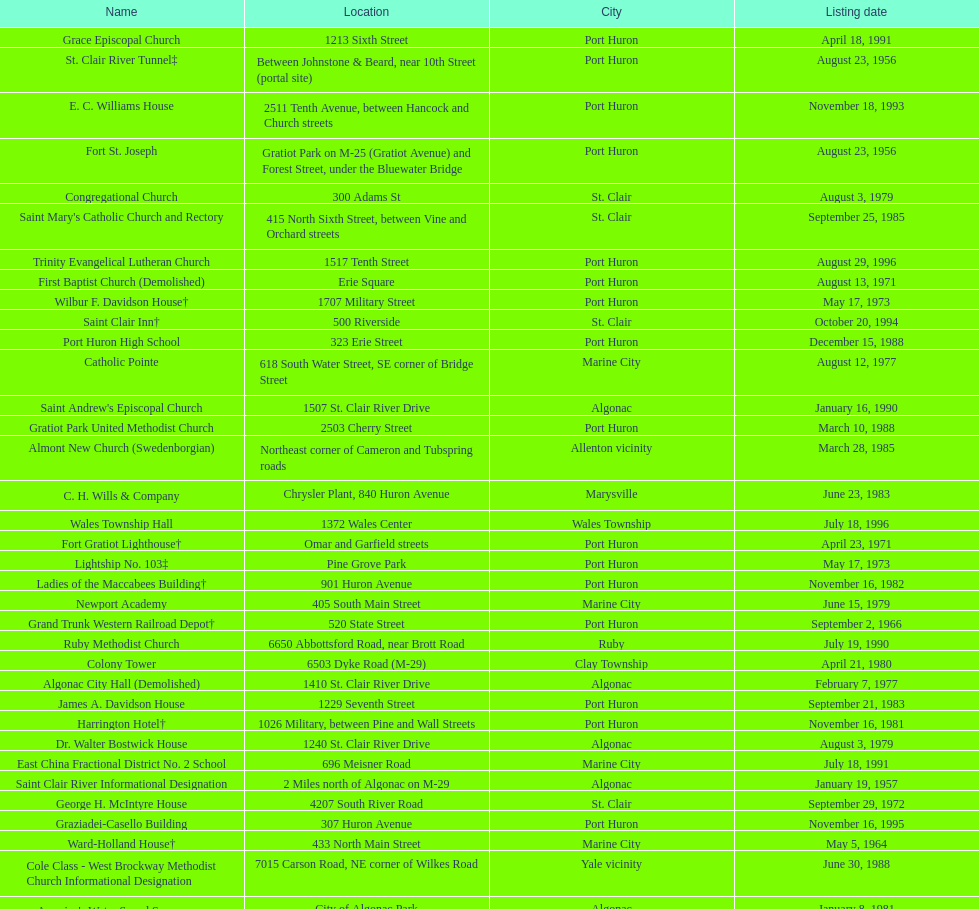Which city is home to the greatest number of historic sites, existing or demolished? Port Huron. 